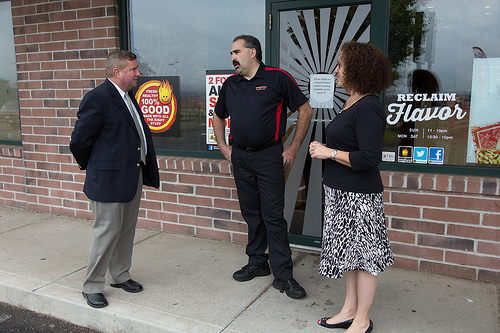<image>
Is there a man to the left of the girl? Yes. From this viewpoint, the man is positioned to the left side relative to the girl. Where is the woman in relation to the man? Is it next to the man? Yes. The woman is positioned adjacent to the man, located nearby in the same general area. 